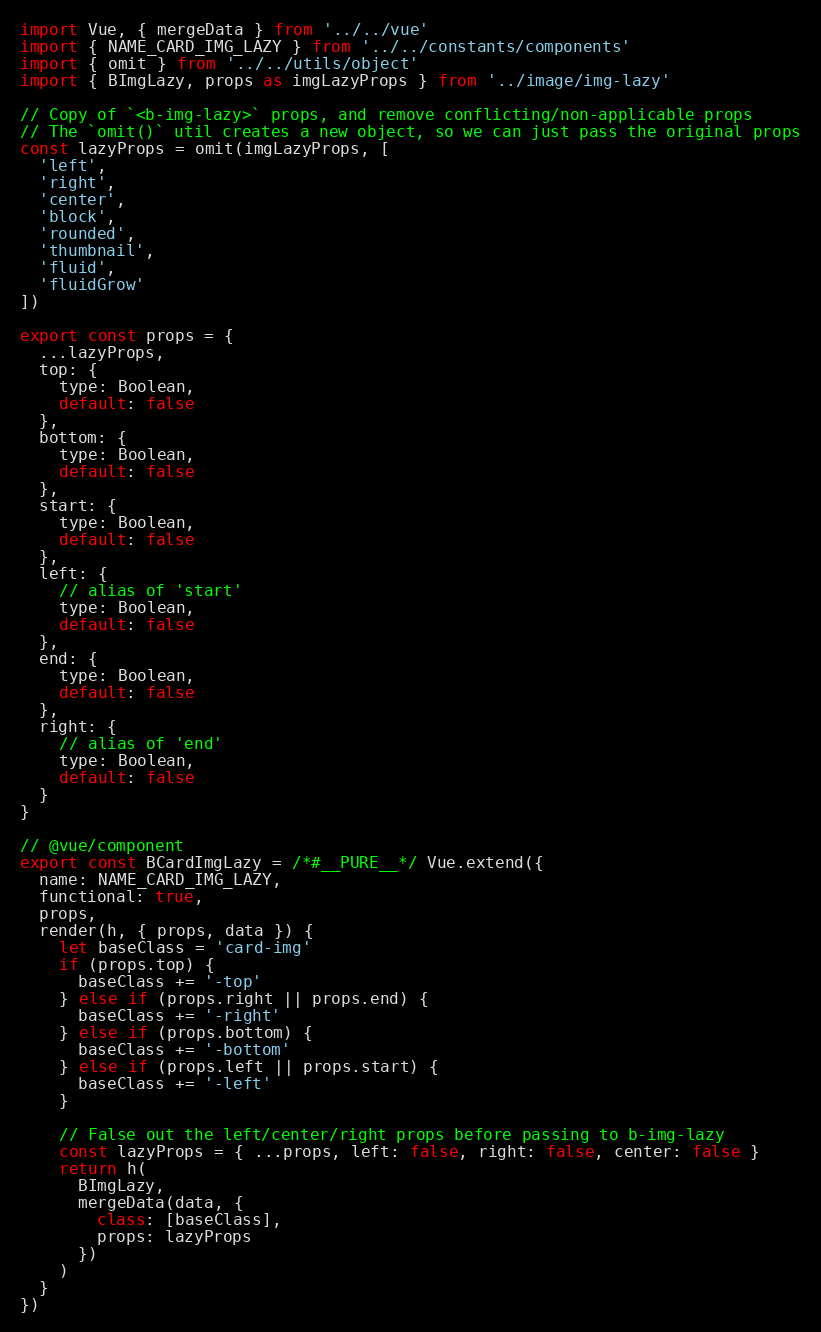Convert code to text. <code><loc_0><loc_0><loc_500><loc_500><_JavaScript_>import Vue, { mergeData } from '../../vue'
import { NAME_CARD_IMG_LAZY } from '../../constants/components'
import { omit } from '../../utils/object'
import { BImgLazy, props as imgLazyProps } from '../image/img-lazy'

// Copy of `<b-img-lazy>` props, and remove conflicting/non-applicable props
// The `omit()` util creates a new object, so we can just pass the original props
const lazyProps = omit(imgLazyProps, [
  'left',
  'right',
  'center',
  'block',
  'rounded',
  'thumbnail',
  'fluid',
  'fluidGrow'
])

export const props = {
  ...lazyProps,
  top: {
    type: Boolean,
    default: false
  },
  bottom: {
    type: Boolean,
    default: false
  },
  start: {
    type: Boolean,
    default: false
  },
  left: {
    // alias of 'start'
    type: Boolean,
    default: false
  },
  end: {
    type: Boolean,
    default: false
  },
  right: {
    // alias of 'end'
    type: Boolean,
    default: false
  }
}

// @vue/component
export const BCardImgLazy = /*#__PURE__*/ Vue.extend({
  name: NAME_CARD_IMG_LAZY,
  functional: true,
  props,
  render(h, { props, data }) {
    let baseClass = 'card-img'
    if (props.top) {
      baseClass += '-top'
    } else if (props.right || props.end) {
      baseClass += '-right'
    } else if (props.bottom) {
      baseClass += '-bottom'
    } else if (props.left || props.start) {
      baseClass += '-left'
    }

    // False out the left/center/right props before passing to b-img-lazy
    const lazyProps = { ...props, left: false, right: false, center: false }
    return h(
      BImgLazy,
      mergeData(data, {
        class: [baseClass],
        props: lazyProps
      })
    )
  }
})
</code> 